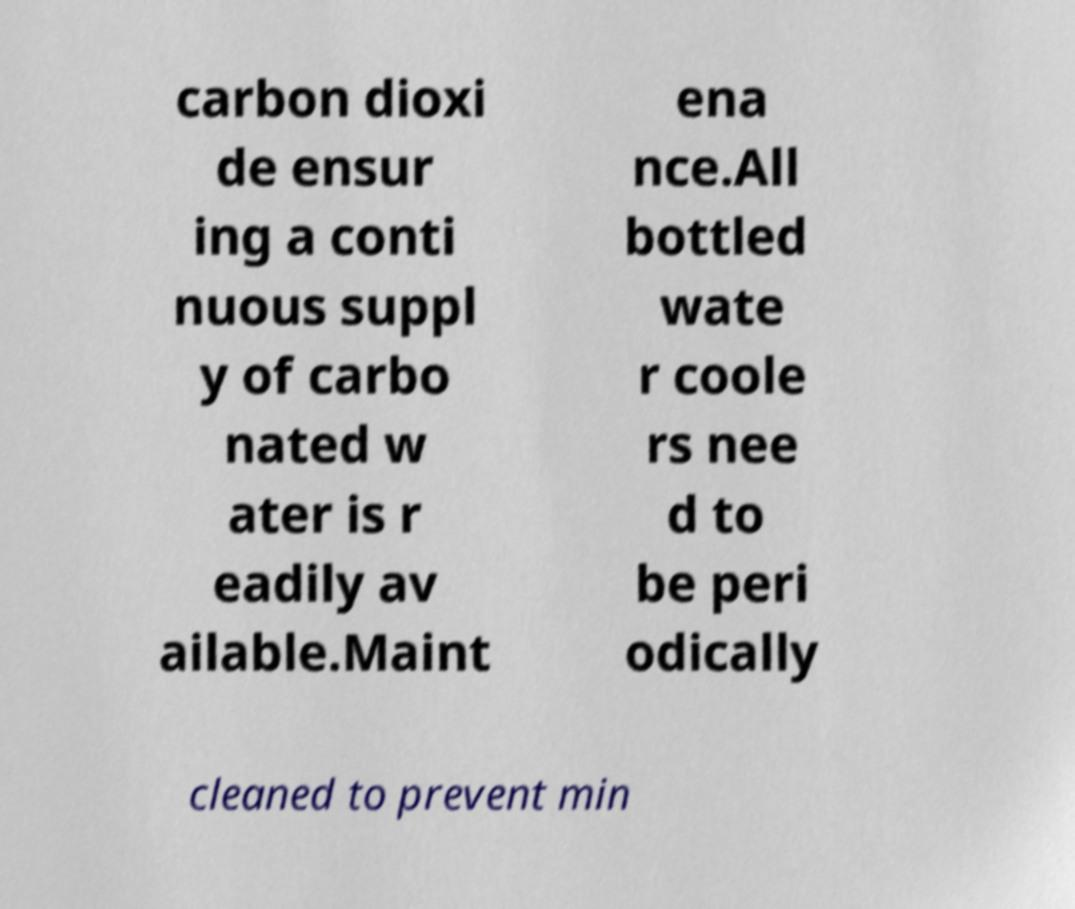There's text embedded in this image that I need extracted. Can you transcribe it verbatim? carbon dioxi de ensur ing a conti nuous suppl y of carbo nated w ater is r eadily av ailable.Maint ena nce.All bottled wate r coole rs nee d to be peri odically cleaned to prevent min 